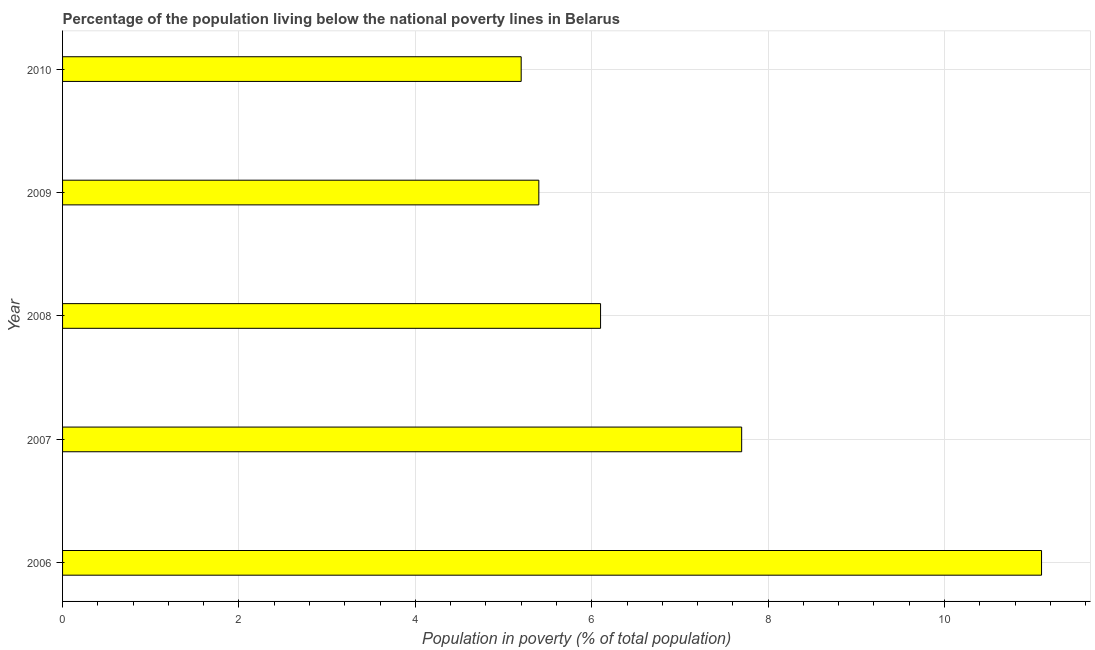Does the graph contain any zero values?
Your answer should be compact. No. What is the title of the graph?
Provide a short and direct response. Percentage of the population living below the national poverty lines in Belarus. What is the label or title of the X-axis?
Ensure brevity in your answer.  Population in poverty (% of total population). What is the label or title of the Y-axis?
Your answer should be compact. Year. What is the percentage of population living below poverty line in 2006?
Keep it short and to the point. 11.1. Across all years, what is the maximum percentage of population living below poverty line?
Offer a terse response. 11.1. In which year was the percentage of population living below poverty line minimum?
Your answer should be compact. 2010. What is the sum of the percentage of population living below poverty line?
Provide a short and direct response. 35.5. What is the difference between the percentage of population living below poverty line in 2006 and 2010?
Keep it short and to the point. 5.9. In how many years, is the percentage of population living below poverty line greater than 5.6 %?
Offer a terse response. 3. What is the ratio of the percentage of population living below poverty line in 2007 to that in 2010?
Offer a terse response. 1.48. Is the sum of the percentage of population living below poverty line in 2007 and 2010 greater than the maximum percentage of population living below poverty line across all years?
Provide a short and direct response. Yes. In how many years, is the percentage of population living below poverty line greater than the average percentage of population living below poverty line taken over all years?
Offer a terse response. 2. Are all the bars in the graph horizontal?
Provide a short and direct response. Yes. What is the difference between two consecutive major ticks on the X-axis?
Keep it short and to the point. 2. Are the values on the major ticks of X-axis written in scientific E-notation?
Your answer should be compact. No. What is the difference between the Population in poverty (% of total population) in 2006 and 2010?
Offer a terse response. 5.9. What is the difference between the Population in poverty (% of total population) in 2007 and 2009?
Offer a very short reply. 2.3. What is the difference between the Population in poverty (% of total population) in 2007 and 2010?
Offer a terse response. 2.5. What is the difference between the Population in poverty (% of total population) in 2008 and 2009?
Your response must be concise. 0.7. What is the difference between the Population in poverty (% of total population) in 2009 and 2010?
Ensure brevity in your answer.  0.2. What is the ratio of the Population in poverty (% of total population) in 2006 to that in 2007?
Keep it short and to the point. 1.44. What is the ratio of the Population in poverty (% of total population) in 2006 to that in 2008?
Make the answer very short. 1.82. What is the ratio of the Population in poverty (% of total population) in 2006 to that in 2009?
Your answer should be compact. 2.06. What is the ratio of the Population in poverty (% of total population) in 2006 to that in 2010?
Provide a short and direct response. 2.13. What is the ratio of the Population in poverty (% of total population) in 2007 to that in 2008?
Keep it short and to the point. 1.26. What is the ratio of the Population in poverty (% of total population) in 2007 to that in 2009?
Offer a very short reply. 1.43. What is the ratio of the Population in poverty (% of total population) in 2007 to that in 2010?
Provide a succinct answer. 1.48. What is the ratio of the Population in poverty (% of total population) in 2008 to that in 2009?
Ensure brevity in your answer.  1.13. What is the ratio of the Population in poverty (% of total population) in 2008 to that in 2010?
Your answer should be compact. 1.17. What is the ratio of the Population in poverty (% of total population) in 2009 to that in 2010?
Give a very brief answer. 1.04. 